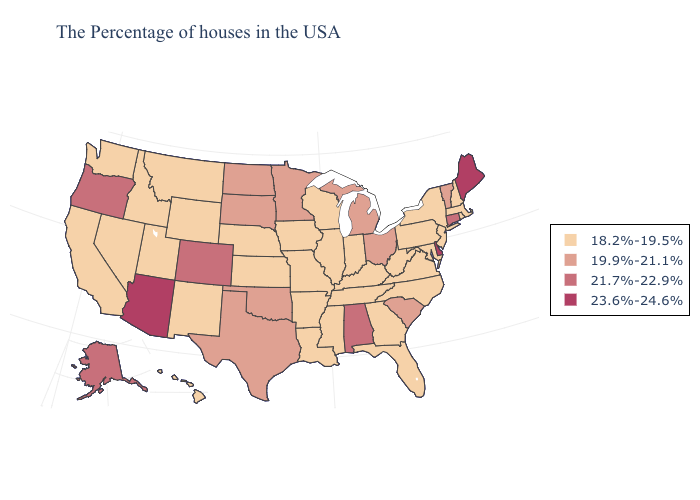Which states have the lowest value in the USA?
Give a very brief answer. Massachusetts, Rhode Island, New Hampshire, New York, New Jersey, Maryland, Pennsylvania, Virginia, North Carolina, West Virginia, Florida, Georgia, Kentucky, Indiana, Tennessee, Wisconsin, Illinois, Mississippi, Louisiana, Missouri, Arkansas, Iowa, Kansas, Nebraska, Wyoming, New Mexico, Utah, Montana, Idaho, Nevada, California, Washington, Hawaii. Does Utah have the same value as Maryland?
Concise answer only. Yes. Name the states that have a value in the range 21.7%-22.9%?
Concise answer only. Connecticut, Alabama, Colorado, Oregon, Alaska. Does South Carolina have the lowest value in the South?
Answer briefly. No. Which states have the highest value in the USA?
Short answer required. Maine, Delaware, Arizona. What is the value of Oklahoma?
Give a very brief answer. 19.9%-21.1%. What is the lowest value in states that border Connecticut?
Give a very brief answer. 18.2%-19.5%. Does the map have missing data?
Give a very brief answer. No. Which states hav the highest value in the Northeast?
Short answer required. Maine. Which states have the highest value in the USA?
Give a very brief answer. Maine, Delaware, Arizona. Does New Hampshire have a lower value than Pennsylvania?
Write a very short answer. No. What is the value of Virginia?
Write a very short answer. 18.2%-19.5%. Name the states that have a value in the range 19.9%-21.1%?
Be succinct. Vermont, South Carolina, Ohio, Michigan, Minnesota, Oklahoma, Texas, South Dakota, North Dakota. Among the states that border Utah , does Colorado have the lowest value?
Quick response, please. No. Name the states that have a value in the range 19.9%-21.1%?
Keep it brief. Vermont, South Carolina, Ohio, Michigan, Minnesota, Oklahoma, Texas, South Dakota, North Dakota. 